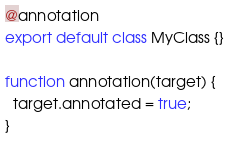<code> <loc_0><loc_0><loc_500><loc_500><_JavaScript_>@annotation
export default class MyClass {}

function annotation(target) {
  target.annotated = true;
}
</code> 